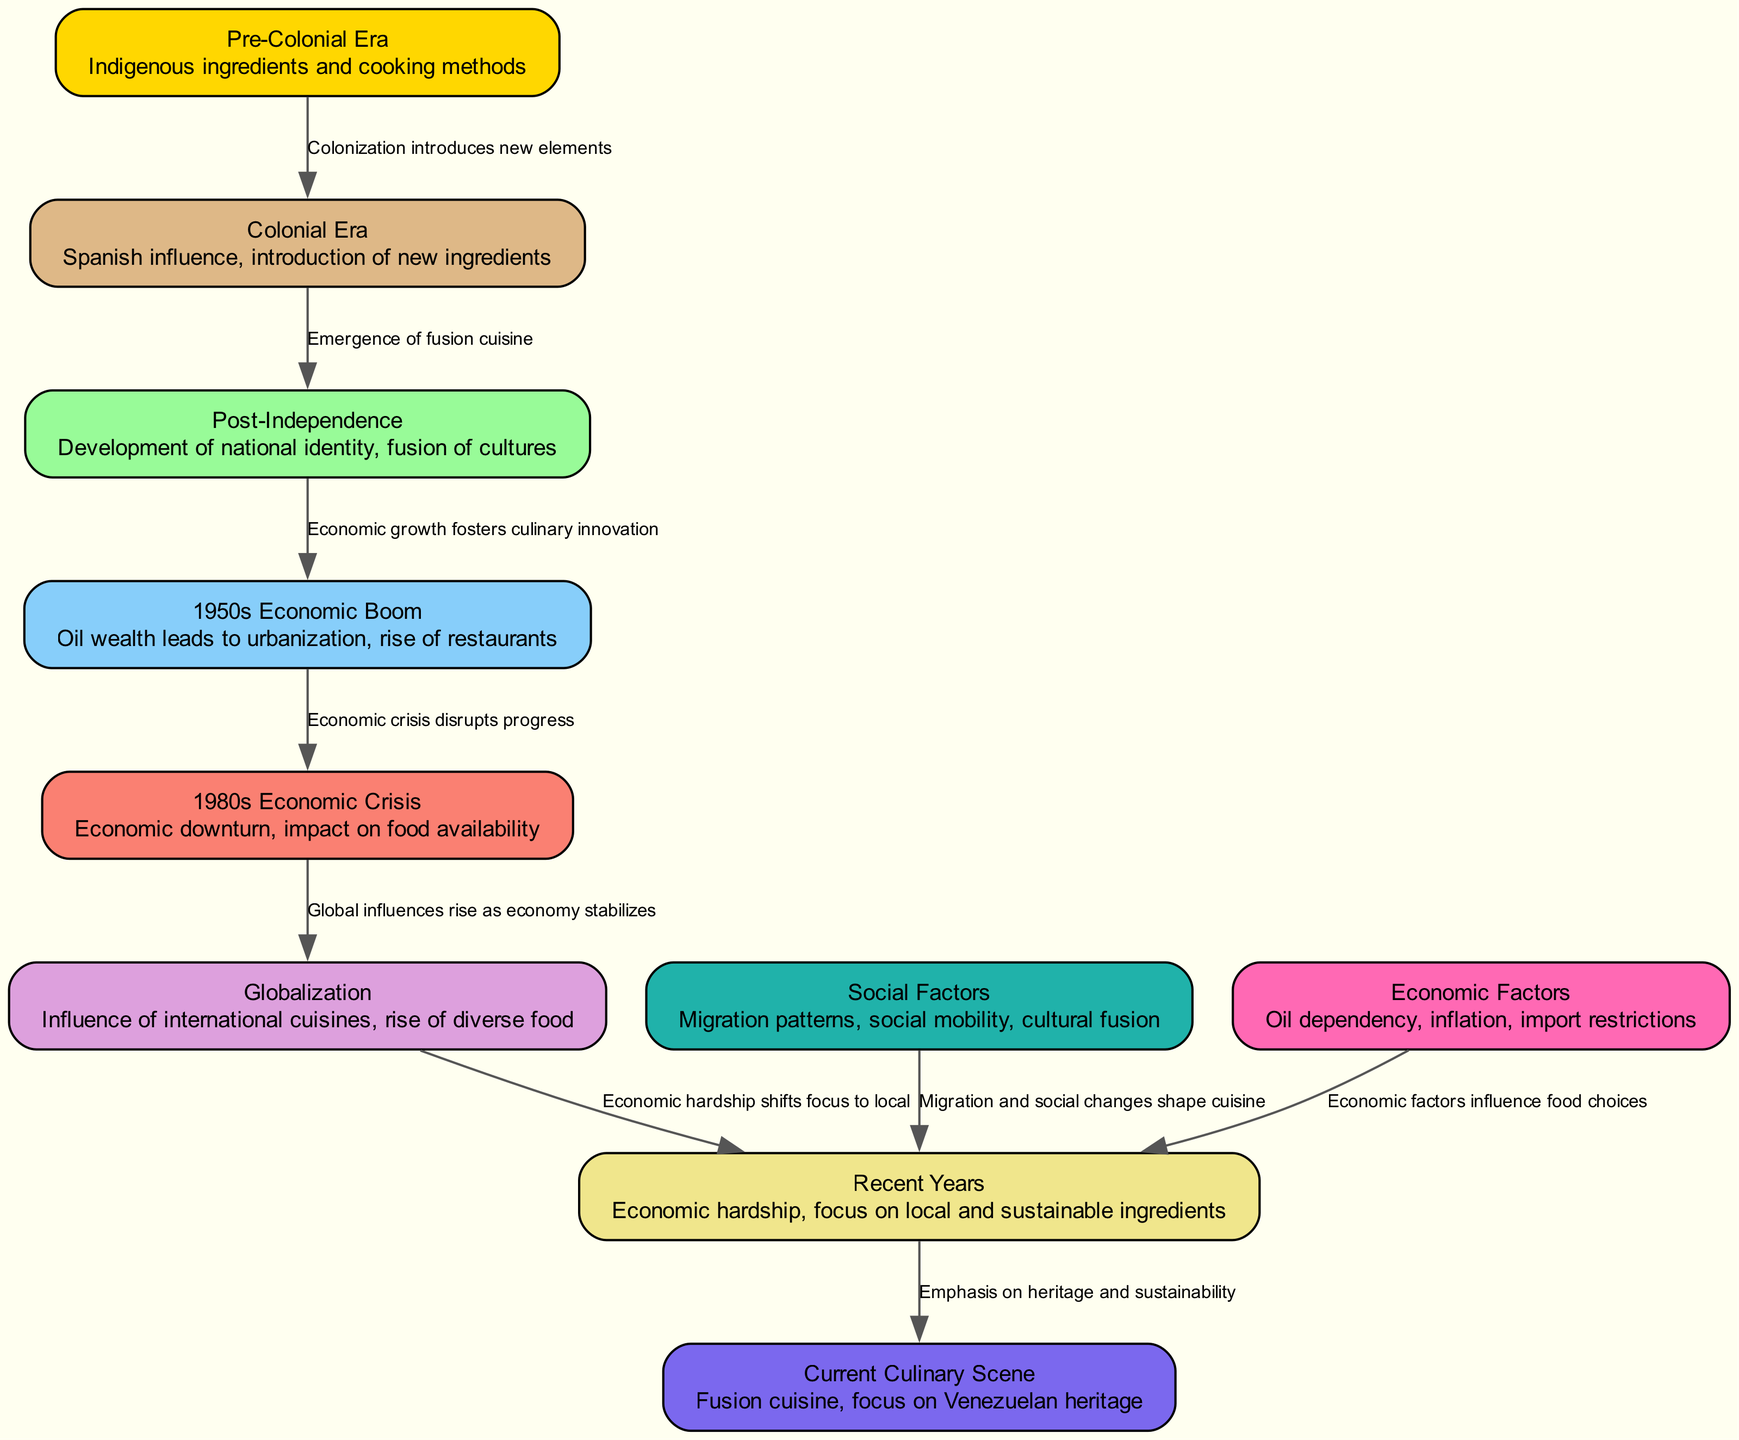What era is represented by the node with Spanish influence? The node labeled "Colonial Era" highlights the Spanish influence and the introduction of new ingredients to Venezuelan cuisine.
Answer: Colonial Era How many nodes are present in the diagram? By counting each individual node listed in the data, we find there are ten nodes total.
Answer: 10 What economic factor disrupted progress in the 1950s? The edge labeled "Economic crisis disrupts progress" connects the nodes from the 1950s Economic Boom to the 1980s Economic Crisis, indicating the economic downturn as a disruptive factor.
Answer: Economic crisis Which node indicates a shift towards local ingredients due to economic hardship? The edge labeled "Economic hardship shifts focus to local" points to the "Recent Years" node, indicating a shift in focus to local and sustainable ingredients due to economic hardship.
Answer: Recent Years What followed the Colonial Era in the evolution of Venezuelan cuisine? The diagram shows that the "Post-Independence" node directly follows the "Colonial Era" node, indicating the emergence of a new cultural identity and fusion cuisine.
Answer: Post-Independence What is the relationship between the 1980s Economic Crisis and Globalization? The edge labeled "Global influences rise as economy stabilizes" connects the "1980s Economic Crisis" to the "Globalization" node, suggesting that economic stabilization after the crisis allowed globalization to rise.
Answer: Global influences rise as economy stabilizes Which node emphasizes a focus on Venezuelan heritage in the current culinary scene? The edge labeled "Emphasis on heritage and sustainability" shows the direct connection from "Recent Years" to the "Current Culinary Scene," pointing to a focus on Venezuelan heritage.
Answer: Current Culinary Scene How does migration relate to recent years in Venezuelan cuisine? The edge labeled "Migration and social changes shape cuisine" connects "Social Factors" to "Recent Years," illustrating how social changes due to migration impacted the cuisine during that time.
Answer: Migration and social changes shape cuisine What node indicates the development of a national identity? The node labeled "Post-Independence" highlights the development of a national identity and the subsequent fusion of various cultures in Venezuelan cuisine.
Answer: Post-Independence 